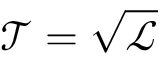<formula> <loc_0><loc_0><loc_500><loc_500>\ m a t h s c r { T } = \sqrt { \ m a t h s c r { L } }</formula> 